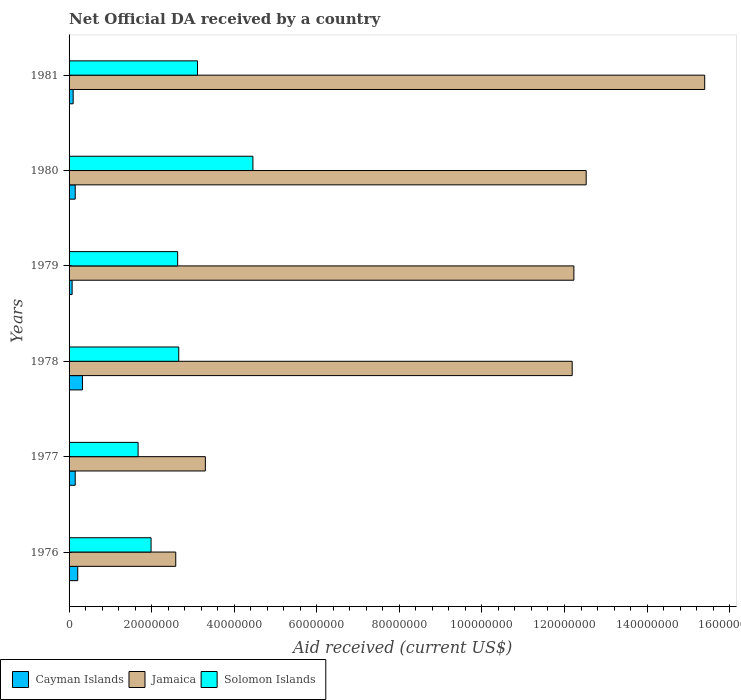How many groups of bars are there?
Your answer should be very brief. 6. What is the label of the 6th group of bars from the top?
Ensure brevity in your answer.  1976. In how many cases, is the number of bars for a given year not equal to the number of legend labels?
Make the answer very short. 0. What is the net official development assistance aid received in Solomon Islands in 1981?
Provide a succinct answer. 3.11e+07. Across all years, what is the maximum net official development assistance aid received in Cayman Islands?
Give a very brief answer. 3.24e+06. Across all years, what is the minimum net official development assistance aid received in Jamaica?
Your response must be concise. 2.58e+07. In which year was the net official development assistance aid received in Cayman Islands maximum?
Provide a succinct answer. 1978. In which year was the net official development assistance aid received in Cayman Islands minimum?
Provide a short and direct response. 1979. What is the total net official development assistance aid received in Solomon Islands in the graph?
Your response must be concise. 1.65e+08. What is the difference between the net official development assistance aid received in Solomon Islands in 1980 and that in 1981?
Offer a very short reply. 1.34e+07. What is the difference between the net official development assistance aid received in Jamaica in 1980 and the net official development assistance aid received in Cayman Islands in 1976?
Your response must be concise. 1.23e+08. What is the average net official development assistance aid received in Solomon Islands per year?
Your answer should be very brief. 2.75e+07. In the year 1977, what is the difference between the net official development assistance aid received in Solomon Islands and net official development assistance aid received in Cayman Islands?
Ensure brevity in your answer.  1.52e+07. What is the ratio of the net official development assistance aid received in Cayman Islands in 1978 to that in 1981?
Your answer should be compact. 3.27. What is the difference between the highest and the second highest net official development assistance aid received in Jamaica?
Give a very brief answer. 2.87e+07. What is the difference between the highest and the lowest net official development assistance aid received in Jamaica?
Give a very brief answer. 1.28e+08. What does the 1st bar from the top in 1978 represents?
Offer a terse response. Solomon Islands. What does the 2nd bar from the bottom in 1978 represents?
Your answer should be compact. Jamaica. What is the difference between two consecutive major ticks on the X-axis?
Offer a very short reply. 2.00e+07. Does the graph contain any zero values?
Give a very brief answer. No. Where does the legend appear in the graph?
Your answer should be compact. Bottom left. How many legend labels are there?
Provide a succinct answer. 3. How are the legend labels stacked?
Your answer should be very brief. Horizontal. What is the title of the graph?
Offer a terse response. Net Official DA received by a country. Does "Lebanon" appear as one of the legend labels in the graph?
Provide a succinct answer. No. What is the label or title of the X-axis?
Your answer should be very brief. Aid received (current US$). What is the Aid received (current US$) in Cayman Islands in 1976?
Make the answer very short. 2.10e+06. What is the Aid received (current US$) of Jamaica in 1976?
Provide a succinct answer. 2.58e+07. What is the Aid received (current US$) in Solomon Islands in 1976?
Your answer should be compact. 1.99e+07. What is the Aid received (current US$) in Cayman Islands in 1977?
Offer a very short reply. 1.49e+06. What is the Aid received (current US$) of Jamaica in 1977?
Offer a terse response. 3.30e+07. What is the Aid received (current US$) in Solomon Islands in 1977?
Your answer should be compact. 1.67e+07. What is the Aid received (current US$) of Cayman Islands in 1978?
Your answer should be very brief. 3.24e+06. What is the Aid received (current US$) in Jamaica in 1978?
Your answer should be very brief. 1.22e+08. What is the Aid received (current US$) of Solomon Islands in 1978?
Provide a short and direct response. 2.66e+07. What is the Aid received (current US$) in Cayman Islands in 1979?
Ensure brevity in your answer.  7.40e+05. What is the Aid received (current US$) of Jamaica in 1979?
Keep it short and to the point. 1.22e+08. What is the Aid received (current US$) of Solomon Islands in 1979?
Your answer should be very brief. 2.63e+07. What is the Aid received (current US$) of Cayman Islands in 1980?
Your answer should be very brief. 1.49e+06. What is the Aid received (current US$) of Jamaica in 1980?
Keep it short and to the point. 1.25e+08. What is the Aid received (current US$) in Solomon Islands in 1980?
Provide a succinct answer. 4.45e+07. What is the Aid received (current US$) in Cayman Islands in 1981?
Offer a very short reply. 9.90e+05. What is the Aid received (current US$) of Jamaica in 1981?
Your answer should be very brief. 1.54e+08. What is the Aid received (current US$) in Solomon Islands in 1981?
Provide a short and direct response. 3.11e+07. Across all years, what is the maximum Aid received (current US$) in Cayman Islands?
Provide a short and direct response. 3.24e+06. Across all years, what is the maximum Aid received (current US$) in Jamaica?
Offer a very short reply. 1.54e+08. Across all years, what is the maximum Aid received (current US$) in Solomon Islands?
Your answer should be compact. 4.45e+07. Across all years, what is the minimum Aid received (current US$) in Cayman Islands?
Provide a succinct answer. 7.40e+05. Across all years, what is the minimum Aid received (current US$) in Jamaica?
Your answer should be compact. 2.58e+07. Across all years, what is the minimum Aid received (current US$) of Solomon Islands?
Provide a short and direct response. 1.67e+07. What is the total Aid received (current US$) of Cayman Islands in the graph?
Make the answer very short. 1.00e+07. What is the total Aid received (current US$) in Jamaica in the graph?
Your answer should be very brief. 5.82e+08. What is the total Aid received (current US$) of Solomon Islands in the graph?
Your answer should be very brief. 1.65e+08. What is the difference between the Aid received (current US$) in Cayman Islands in 1976 and that in 1977?
Your answer should be compact. 6.10e+05. What is the difference between the Aid received (current US$) in Jamaica in 1976 and that in 1977?
Offer a terse response. -7.17e+06. What is the difference between the Aid received (current US$) in Solomon Islands in 1976 and that in 1977?
Give a very brief answer. 3.14e+06. What is the difference between the Aid received (current US$) in Cayman Islands in 1976 and that in 1978?
Provide a short and direct response. -1.14e+06. What is the difference between the Aid received (current US$) of Jamaica in 1976 and that in 1978?
Your response must be concise. -9.60e+07. What is the difference between the Aid received (current US$) in Solomon Islands in 1976 and that in 1978?
Keep it short and to the point. -6.70e+06. What is the difference between the Aid received (current US$) in Cayman Islands in 1976 and that in 1979?
Give a very brief answer. 1.36e+06. What is the difference between the Aid received (current US$) in Jamaica in 1976 and that in 1979?
Offer a terse response. -9.64e+07. What is the difference between the Aid received (current US$) of Solomon Islands in 1976 and that in 1979?
Offer a very short reply. -6.44e+06. What is the difference between the Aid received (current US$) in Jamaica in 1976 and that in 1980?
Provide a succinct answer. -9.94e+07. What is the difference between the Aid received (current US$) of Solomon Islands in 1976 and that in 1980?
Ensure brevity in your answer.  -2.47e+07. What is the difference between the Aid received (current US$) of Cayman Islands in 1976 and that in 1981?
Offer a terse response. 1.11e+06. What is the difference between the Aid received (current US$) in Jamaica in 1976 and that in 1981?
Ensure brevity in your answer.  -1.28e+08. What is the difference between the Aid received (current US$) in Solomon Islands in 1976 and that in 1981?
Your response must be concise. -1.12e+07. What is the difference between the Aid received (current US$) in Cayman Islands in 1977 and that in 1978?
Keep it short and to the point. -1.75e+06. What is the difference between the Aid received (current US$) of Jamaica in 1977 and that in 1978?
Your answer should be very brief. -8.88e+07. What is the difference between the Aid received (current US$) of Solomon Islands in 1977 and that in 1978?
Give a very brief answer. -9.84e+06. What is the difference between the Aid received (current US$) of Cayman Islands in 1977 and that in 1979?
Offer a very short reply. 7.50e+05. What is the difference between the Aid received (current US$) of Jamaica in 1977 and that in 1979?
Make the answer very short. -8.93e+07. What is the difference between the Aid received (current US$) in Solomon Islands in 1977 and that in 1979?
Keep it short and to the point. -9.58e+06. What is the difference between the Aid received (current US$) of Cayman Islands in 1977 and that in 1980?
Your answer should be compact. 0. What is the difference between the Aid received (current US$) of Jamaica in 1977 and that in 1980?
Your answer should be compact. -9.22e+07. What is the difference between the Aid received (current US$) of Solomon Islands in 1977 and that in 1980?
Offer a very short reply. -2.78e+07. What is the difference between the Aid received (current US$) in Cayman Islands in 1977 and that in 1981?
Ensure brevity in your answer.  5.00e+05. What is the difference between the Aid received (current US$) of Jamaica in 1977 and that in 1981?
Your answer should be very brief. -1.21e+08. What is the difference between the Aid received (current US$) in Solomon Islands in 1977 and that in 1981?
Your response must be concise. -1.44e+07. What is the difference between the Aid received (current US$) of Cayman Islands in 1978 and that in 1979?
Your response must be concise. 2.50e+06. What is the difference between the Aid received (current US$) of Jamaica in 1978 and that in 1979?
Provide a succinct answer. -4.10e+05. What is the difference between the Aid received (current US$) of Solomon Islands in 1978 and that in 1979?
Offer a very short reply. 2.60e+05. What is the difference between the Aid received (current US$) of Cayman Islands in 1978 and that in 1980?
Your response must be concise. 1.75e+06. What is the difference between the Aid received (current US$) in Jamaica in 1978 and that in 1980?
Your response must be concise. -3.39e+06. What is the difference between the Aid received (current US$) in Solomon Islands in 1978 and that in 1980?
Keep it short and to the point. -1.80e+07. What is the difference between the Aid received (current US$) in Cayman Islands in 1978 and that in 1981?
Your answer should be compact. 2.25e+06. What is the difference between the Aid received (current US$) in Jamaica in 1978 and that in 1981?
Your answer should be very brief. -3.21e+07. What is the difference between the Aid received (current US$) of Solomon Islands in 1978 and that in 1981?
Give a very brief answer. -4.55e+06. What is the difference between the Aid received (current US$) in Cayman Islands in 1979 and that in 1980?
Offer a terse response. -7.50e+05. What is the difference between the Aid received (current US$) of Jamaica in 1979 and that in 1980?
Provide a succinct answer. -2.98e+06. What is the difference between the Aid received (current US$) of Solomon Islands in 1979 and that in 1980?
Make the answer very short. -1.82e+07. What is the difference between the Aid received (current US$) of Cayman Islands in 1979 and that in 1981?
Provide a succinct answer. -2.50e+05. What is the difference between the Aid received (current US$) in Jamaica in 1979 and that in 1981?
Your answer should be compact. -3.17e+07. What is the difference between the Aid received (current US$) in Solomon Islands in 1979 and that in 1981?
Keep it short and to the point. -4.81e+06. What is the difference between the Aid received (current US$) in Jamaica in 1980 and that in 1981?
Offer a very short reply. -2.87e+07. What is the difference between the Aid received (current US$) in Solomon Islands in 1980 and that in 1981?
Offer a very short reply. 1.34e+07. What is the difference between the Aid received (current US$) in Cayman Islands in 1976 and the Aid received (current US$) in Jamaica in 1977?
Give a very brief answer. -3.09e+07. What is the difference between the Aid received (current US$) of Cayman Islands in 1976 and the Aid received (current US$) of Solomon Islands in 1977?
Ensure brevity in your answer.  -1.46e+07. What is the difference between the Aid received (current US$) of Jamaica in 1976 and the Aid received (current US$) of Solomon Islands in 1977?
Keep it short and to the point. 9.12e+06. What is the difference between the Aid received (current US$) of Cayman Islands in 1976 and the Aid received (current US$) of Jamaica in 1978?
Ensure brevity in your answer.  -1.20e+08. What is the difference between the Aid received (current US$) of Cayman Islands in 1976 and the Aid received (current US$) of Solomon Islands in 1978?
Provide a short and direct response. -2.45e+07. What is the difference between the Aid received (current US$) of Jamaica in 1976 and the Aid received (current US$) of Solomon Islands in 1978?
Provide a succinct answer. -7.20e+05. What is the difference between the Aid received (current US$) in Cayman Islands in 1976 and the Aid received (current US$) in Jamaica in 1979?
Make the answer very short. -1.20e+08. What is the difference between the Aid received (current US$) in Cayman Islands in 1976 and the Aid received (current US$) in Solomon Islands in 1979?
Make the answer very short. -2.42e+07. What is the difference between the Aid received (current US$) in Jamaica in 1976 and the Aid received (current US$) in Solomon Islands in 1979?
Keep it short and to the point. -4.60e+05. What is the difference between the Aid received (current US$) of Cayman Islands in 1976 and the Aid received (current US$) of Jamaica in 1980?
Offer a terse response. -1.23e+08. What is the difference between the Aid received (current US$) in Cayman Islands in 1976 and the Aid received (current US$) in Solomon Islands in 1980?
Make the answer very short. -4.24e+07. What is the difference between the Aid received (current US$) in Jamaica in 1976 and the Aid received (current US$) in Solomon Islands in 1980?
Your response must be concise. -1.87e+07. What is the difference between the Aid received (current US$) in Cayman Islands in 1976 and the Aid received (current US$) in Jamaica in 1981?
Offer a very short reply. -1.52e+08. What is the difference between the Aid received (current US$) of Cayman Islands in 1976 and the Aid received (current US$) of Solomon Islands in 1981?
Provide a short and direct response. -2.90e+07. What is the difference between the Aid received (current US$) in Jamaica in 1976 and the Aid received (current US$) in Solomon Islands in 1981?
Your answer should be very brief. -5.27e+06. What is the difference between the Aid received (current US$) in Cayman Islands in 1977 and the Aid received (current US$) in Jamaica in 1978?
Ensure brevity in your answer.  -1.20e+08. What is the difference between the Aid received (current US$) in Cayman Islands in 1977 and the Aid received (current US$) in Solomon Islands in 1978?
Ensure brevity in your answer.  -2.51e+07. What is the difference between the Aid received (current US$) in Jamaica in 1977 and the Aid received (current US$) in Solomon Islands in 1978?
Keep it short and to the point. 6.45e+06. What is the difference between the Aid received (current US$) in Cayman Islands in 1977 and the Aid received (current US$) in Jamaica in 1979?
Provide a succinct answer. -1.21e+08. What is the difference between the Aid received (current US$) of Cayman Islands in 1977 and the Aid received (current US$) of Solomon Islands in 1979?
Provide a short and direct response. -2.48e+07. What is the difference between the Aid received (current US$) of Jamaica in 1977 and the Aid received (current US$) of Solomon Islands in 1979?
Ensure brevity in your answer.  6.71e+06. What is the difference between the Aid received (current US$) of Cayman Islands in 1977 and the Aid received (current US$) of Jamaica in 1980?
Keep it short and to the point. -1.24e+08. What is the difference between the Aid received (current US$) of Cayman Islands in 1977 and the Aid received (current US$) of Solomon Islands in 1980?
Give a very brief answer. -4.30e+07. What is the difference between the Aid received (current US$) of Jamaica in 1977 and the Aid received (current US$) of Solomon Islands in 1980?
Your response must be concise. -1.15e+07. What is the difference between the Aid received (current US$) in Cayman Islands in 1977 and the Aid received (current US$) in Jamaica in 1981?
Provide a short and direct response. -1.52e+08. What is the difference between the Aid received (current US$) in Cayman Islands in 1977 and the Aid received (current US$) in Solomon Islands in 1981?
Ensure brevity in your answer.  -2.96e+07. What is the difference between the Aid received (current US$) in Jamaica in 1977 and the Aid received (current US$) in Solomon Islands in 1981?
Ensure brevity in your answer.  1.90e+06. What is the difference between the Aid received (current US$) in Cayman Islands in 1978 and the Aid received (current US$) in Jamaica in 1979?
Your answer should be compact. -1.19e+08. What is the difference between the Aid received (current US$) of Cayman Islands in 1978 and the Aid received (current US$) of Solomon Islands in 1979?
Provide a succinct answer. -2.31e+07. What is the difference between the Aid received (current US$) in Jamaica in 1978 and the Aid received (current US$) in Solomon Islands in 1979?
Make the answer very short. 9.56e+07. What is the difference between the Aid received (current US$) in Cayman Islands in 1978 and the Aid received (current US$) in Jamaica in 1980?
Offer a terse response. -1.22e+08. What is the difference between the Aid received (current US$) in Cayman Islands in 1978 and the Aid received (current US$) in Solomon Islands in 1980?
Your answer should be compact. -4.13e+07. What is the difference between the Aid received (current US$) of Jamaica in 1978 and the Aid received (current US$) of Solomon Islands in 1980?
Keep it short and to the point. 7.73e+07. What is the difference between the Aid received (current US$) of Cayman Islands in 1978 and the Aid received (current US$) of Jamaica in 1981?
Make the answer very short. -1.51e+08. What is the difference between the Aid received (current US$) of Cayman Islands in 1978 and the Aid received (current US$) of Solomon Islands in 1981?
Keep it short and to the point. -2.79e+07. What is the difference between the Aid received (current US$) of Jamaica in 1978 and the Aid received (current US$) of Solomon Islands in 1981?
Offer a very short reply. 9.08e+07. What is the difference between the Aid received (current US$) in Cayman Islands in 1979 and the Aid received (current US$) in Jamaica in 1980?
Offer a very short reply. -1.25e+08. What is the difference between the Aid received (current US$) of Cayman Islands in 1979 and the Aid received (current US$) of Solomon Islands in 1980?
Your response must be concise. -4.38e+07. What is the difference between the Aid received (current US$) in Jamaica in 1979 and the Aid received (current US$) in Solomon Islands in 1980?
Ensure brevity in your answer.  7.77e+07. What is the difference between the Aid received (current US$) of Cayman Islands in 1979 and the Aid received (current US$) of Jamaica in 1981?
Give a very brief answer. -1.53e+08. What is the difference between the Aid received (current US$) in Cayman Islands in 1979 and the Aid received (current US$) in Solomon Islands in 1981?
Your answer should be very brief. -3.04e+07. What is the difference between the Aid received (current US$) in Jamaica in 1979 and the Aid received (current US$) in Solomon Islands in 1981?
Provide a short and direct response. 9.12e+07. What is the difference between the Aid received (current US$) in Cayman Islands in 1980 and the Aid received (current US$) in Jamaica in 1981?
Ensure brevity in your answer.  -1.52e+08. What is the difference between the Aid received (current US$) of Cayman Islands in 1980 and the Aid received (current US$) of Solomon Islands in 1981?
Your response must be concise. -2.96e+07. What is the difference between the Aid received (current US$) in Jamaica in 1980 and the Aid received (current US$) in Solomon Islands in 1981?
Provide a short and direct response. 9.41e+07. What is the average Aid received (current US$) of Cayman Islands per year?
Make the answer very short. 1.68e+06. What is the average Aid received (current US$) in Jamaica per year?
Keep it short and to the point. 9.70e+07. What is the average Aid received (current US$) of Solomon Islands per year?
Make the answer very short. 2.75e+07. In the year 1976, what is the difference between the Aid received (current US$) in Cayman Islands and Aid received (current US$) in Jamaica?
Your response must be concise. -2.37e+07. In the year 1976, what is the difference between the Aid received (current US$) of Cayman Islands and Aid received (current US$) of Solomon Islands?
Provide a short and direct response. -1.78e+07. In the year 1976, what is the difference between the Aid received (current US$) of Jamaica and Aid received (current US$) of Solomon Islands?
Keep it short and to the point. 5.98e+06. In the year 1977, what is the difference between the Aid received (current US$) in Cayman Islands and Aid received (current US$) in Jamaica?
Your response must be concise. -3.15e+07. In the year 1977, what is the difference between the Aid received (current US$) of Cayman Islands and Aid received (current US$) of Solomon Islands?
Your response must be concise. -1.52e+07. In the year 1977, what is the difference between the Aid received (current US$) of Jamaica and Aid received (current US$) of Solomon Islands?
Make the answer very short. 1.63e+07. In the year 1978, what is the difference between the Aid received (current US$) in Cayman Islands and Aid received (current US$) in Jamaica?
Make the answer very short. -1.19e+08. In the year 1978, what is the difference between the Aid received (current US$) in Cayman Islands and Aid received (current US$) in Solomon Islands?
Make the answer very short. -2.33e+07. In the year 1978, what is the difference between the Aid received (current US$) of Jamaica and Aid received (current US$) of Solomon Islands?
Provide a succinct answer. 9.53e+07. In the year 1979, what is the difference between the Aid received (current US$) in Cayman Islands and Aid received (current US$) in Jamaica?
Make the answer very short. -1.22e+08. In the year 1979, what is the difference between the Aid received (current US$) in Cayman Islands and Aid received (current US$) in Solomon Islands?
Offer a very short reply. -2.56e+07. In the year 1979, what is the difference between the Aid received (current US$) of Jamaica and Aid received (current US$) of Solomon Islands?
Your answer should be very brief. 9.60e+07. In the year 1980, what is the difference between the Aid received (current US$) in Cayman Islands and Aid received (current US$) in Jamaica?
Make the answer very short. -1.24e+08. In the year 1980, what is the difference between the Aid received (current US$) of Cayman Islands and Aid received (current US$) of Solomon Islands?
Offer a terse response. -4.30e+07. In the year 1980, what is the difference between the Aid received (current US$) of Jamaica and Aid received (current US$) of Solomon Islands?
Give a very brief answer. 8.07e+07. In the year 1981, what is the difference between the Aid received (current US$) in Cayman Islands and Aid received (current US$) in Jamaica?
Provide a succinct answer. -1.53e+08. In the year 1981, what is the difference between the Aid received (current US$) of Cayman Islands and Aid received (current US$) of Solomon Islands?
Offer a terse response. -3.01e+07. In the year 1981, what is the difference between the Aid received (current US$) of Jamaica and Aid received (current US$) of Solomon Islands?
Provide a succinct answer. 1.23e+08. What is the ratio of the Aid received (current US$) of Cayman Islands in 1976 to that in 1977?
Provide a succinct answer. 1.41. What is the ratio of the Aid received (current US$) in Jamaica in 1976 to that in 1977?
Keep it short and to the point. 0.78. What is the ratio of the Aid received (current US$) of Solomon Islands in 1976 to that in 1977?
Ensure brevity in your answer.  1.19. What is the ratio of the Aid received (current US$) in Cayman Islands in 1976 to that in 1978?
Make the answer very short. 0.65. What is the ratio of the Aid received (current US$) of Jamaica in 1976 to that in 1978?
Keep it short and to the point. 0.21. What is the ratio of the Aid received (current US$) in Solomon Islands in 1976 to that in 1978?
Your response must be concise. 0.75. What is the ratio of the Aid received (current US$) in Cayman Islands in 1976 to that in 1979?
Your response must be concise. 2.84. What is the ratio of the Aid received (current US$) in Jamaica in 1976 to that in 1979?
Provide a succinct answer. 0.21. What is the ratio of the Aid received (current US$) in Solomon Islands in 1976 to that in 1979?
Your answer should be compact. 0.76. What is the ratio of the Aid received (current US$) of Cayman Islands in 1976 to that in 1980?
Make the answer very short. 1.41. What is the ratio of the Aid received (current US$) in Jamaica in 1976 to that in 1980?
Provide a succinct answer. 0.21. What is the ratio of the Aid received (current US$) of Solomon Islands in 1976 to that in 1980?
Give a very brief answer. 0.45. What is the ratio of the Aid received (current US$) of Cayman Islands in 1976 to that in 1981?
Give a very brief answer. 2.12. What is the ratio of the Aid received (current US$) of Jamaica in 1976 to that in 1981?
Provide a succinct answer. 0.17. What is the ratio of the Aid received (current US$) in Solomon Islands in 1976 to that in 1981?
Your response must be concise. 0.64. What is the ratio of the Aid received (current US$) of Cayman Islands in 1977 to that in 1978?
Your answer should be compact. 0.46. What is the ratio of the Aid received (current US$) of Jamaica in 1977 to that in 1978?
Keep it short and to the point. 0.27. What is the ratio of the Aid received (current US$) of Solomon Islands in 1977 to that in 1978?
Give a very brief answer. 0.63. What is the ratio of the Aid received (current US$) in Cayman Islands in 1977 to that in 1979?
Offer a terse response. 2.01. What is the ratio of the Aid received (current US$) in Jamaica in 1977 to that in 1979?
Your answer should be very brief. 0.27. What is the ratio of the Aid received (current US$) of Solomon Islands in 1977 to that in 1979?
Make the answer very short. 0.64. What is the ratio of the Aid received (current US$) in Cayman Islands in 1977 to that in 1980?
Your response must be concise. 1. What is the ratio of the Aid received (current US$) in Jamaica in 1977 to that in 1980?
Your answer should be compact. 0.26. What is the ratio of the Aid received (current US$) of Solomon Islands in 1977 to that in 1980?
Offer a terse response. 0.38. What is the ratio of the Aid received (current US$) in Cayman Islands in 1977 to that in 1981?
Ensure brevity in your answer.  1.51. What is the ratio of the Aid received (current US$) in Jamaica in 1977 to that in 1981?
Keep it short and to the point. 0.21. What is the ratio of the Aid received (current US$) in Solomon Islands in 1977 to that in 1981?
Offer a terse response. 0.54. What is the ratio of the Aid received (current US$) in Cayman Islands in 1978 to that in 1979?
Give a very brief answer. 4.38. What is the ratio of the Aid received (current US$) in Solomon Islands in 1978 to that in 1979?
Keep it short and to the point. 1.01. What is the ratio of the Aid received (current US$) in Cayman Islands in 1978 to that in 1980?
Ensure brevity in your answer.  2.17. What is the ratio of the Aid received (current US$) of Jamaica in 1978 to that in 1980?
Offer a terse response. 0.97. What is the ratio of the Aid received (current US$) of Solomon Islands in 1978 to that in 1980?
Ensure brevity in your answer.  0.6. What is the ratio of the Aid received (current US$) of Cayman Islands in 1978 to that in 1981?
Keep it short and to the point. 3.27. What is the ratio of the Aid received (current US$) of Jamaica in 1978 to that in 1981?
Ensure brevity in your answer.  0.79. What is the ratio of the Aid received (current US$) of Solomon Islands in 1978 to that in 1981?
Your response must be concise. 0.85. What is the ratio of the Aid received (current US$) in Cayman Islands in 1979 to that in 1980?
Your answer should be very brief. 0.5. What is the ratio of the Aid received (current US$) in Jamaica in 1979 to that in 1980?
Offer a very short reply. 0.98. What is the ratio of the Aid received (current US$) of Solomon Islands in 1979 to that in 1980?
Make the answer very short. 0.59. What is the ratio of the Aid received (current US$) of Cayman Islands in 1979 to that in 1981?
Keep it short and to the point. 0.75. What is the ratio of the Aid received (current US$) of Jamaica in 1979 to that in 1981?
Your answer should be very brief. 0.79. What is the ratio of the Aid received (current US$) in Solomon Islands in 1979 to that in 1981?
Your response must be concise. 0.85. What is the ratio of the Aid received (current US$) in Cayman Islands in 1980 to that in 1981?
Keep it short and to the point. 1.51. What is the ratio of the Aid received (current US$) of Jamaica in 1980 to that in 1981?
Offer a very short reply. 0.81. What is the ratio of the Aid received (current US$) of Solomon Islands in 1980 to that in 1981?
Offer a very short reply. 1.43. What is the difference between the highest and the second highest Aid received (current US$) of Cayman Islands?
Provide a short and direct response. 1.14e+06. What is the difference between the highest and the second highest Aid received (current US$) in Jamaica?
Your answer should be very brief. 2.87e+07. What is the difference between the highest and the second highest Aid received (current US$) of Solomon Islands?
Make the answer very short. 1.34e+07. What is the difference between the highest and the lowest Aid received (current US$) of Cayman Islands?
Give a very brief answer. 2.50e+06. What is the difference between the highest and the lowest Aid received (current US$) in Jamaica?
Keep it short and to the point. 1.28e+08. What is the difference between the highest and the lowest Aid received (current US$) in Solomon Islands?
Your answer should be very brief. 2.78e+07. 